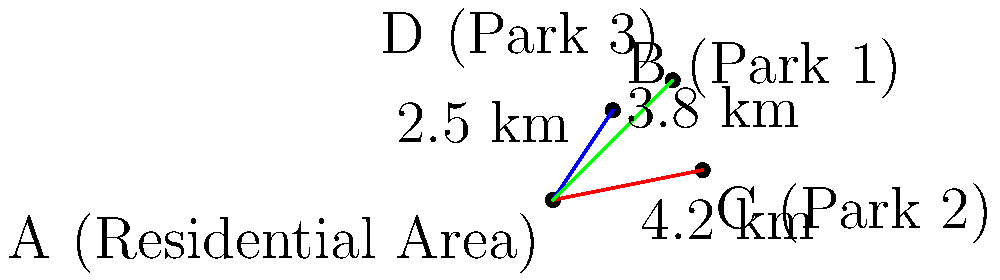The map shows a residential area (A) and three parks (B, C, and D) in Miyun District. Which park is closest to the residential area, and what is the distance between them? To determine which park is closest to the residential area, we need to compare the distances between point A (residential area) and each of the parks:

1. Distance between A and B (Park 1): 2.5 km
2. Distance between A and C (Park 2): 4.2 km
3. Distance between A and D (Park 3): 3.8 km

Comparing these distances:
- 2.5 km < 3.8 km < 4.2 km

Therefore, Park 1 (B) is the closest to the residential area, with a distance of 2.5 km.
Answer: Park 1 (B), 2.5 km 